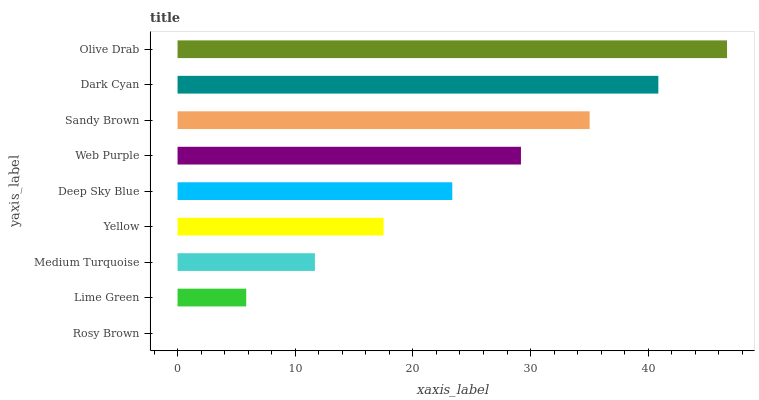Is Rosy Brown the minimum?
Answer yes or no. Yes. Is Olive Drab the maximum?
Answer yes or no. Yes. Is Lime Green the minimum?
Answer yes or no. No. Is Lime Green the maximum?
Answer yes or no. No. Is Lime Green greater than Rosy Brown?
Answer yes or no. Yes. Is Rosy Brown less than Lime Green?
Answer yes or no. Yes. Is Rosy Brown greater than Lime Green?
Answer yes or no. No. Is Lime Green less than Rosy Brown?
Answer yes or no. No. Is Deep Sky Blue the high median?
Answer yes or no. Yes. Is Deep Sky Blue the low median?
Answer yes or no. Yes. Is Sandy Brown the high median?
Answer yes or no. No. Is Web Purple the low median?
Answer yes or no. No. 